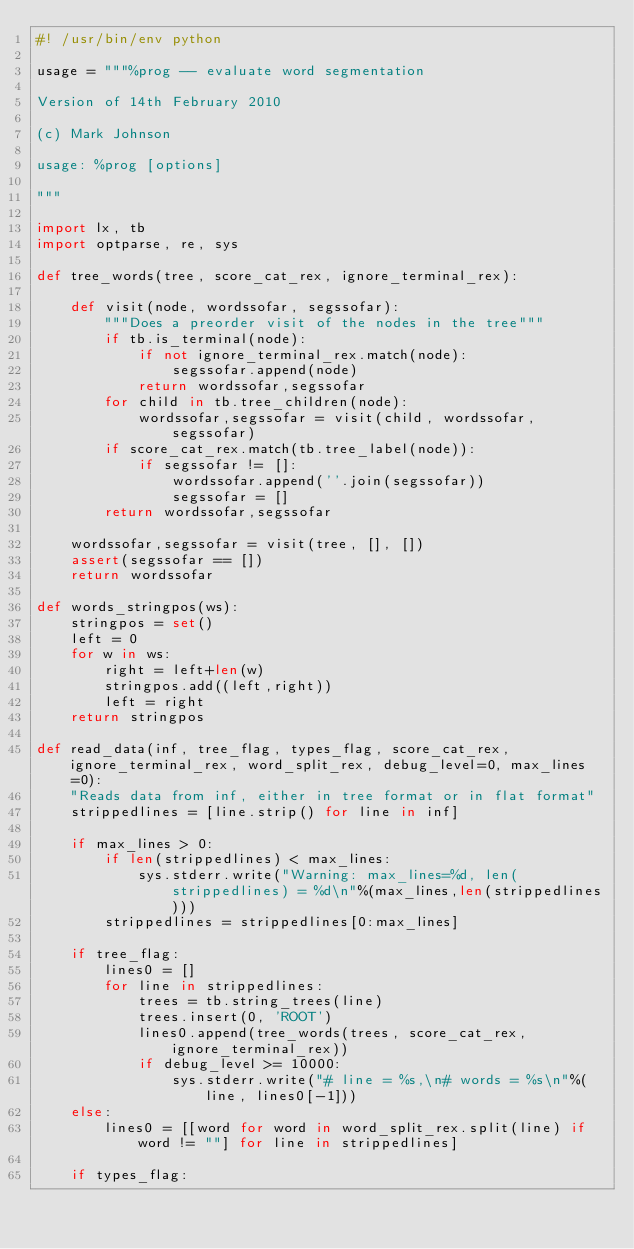<code> <loc_0><loc_0><loc_500><loc_500><_Python_>#! /usr/bin/env python

usage = """%prog -- evaluate word segmentation

Version of 14th February 2010

(c) Mark Johnson

usage: %prog [options]

"""

import lx, tb
import optparse, re, sys

def tree_words(tree, score_cat_rex, ignore_terminal_rex):

    def visit(node, wordssofar, segssofar):
        """Does a preorder visit of the nodes in the tree"""
        if tb.is_terminal(node):
            if not ignore_terminal_rex.match(node):
                segssofar.append(node)
            return wordssofar,segssofar
        for child in tb.tree_children(node):
            wordssofar,segssofar = visit(child, wordssofar, segssofar)
        if score_cat_rex.match(tb.tree_label(node)):
            if segssofar != []:
                wordssofar.append(''.join(segssofar))
                segssofar = []
        return wordssofar,segssofar

    wordssofar,segssofar = visit(tree, [], [])
    assert(segssofar == [])
    return wordssofar

def words_stringpos(ws):
    stringpos = set()
    left = 0
    for w in ws:
        right = left+len(w)
        stringpos.add((left,right))
        left = right
    return stringpos
    
def read_data(inf, tree_flag, types_flag, score_cat_rex, ignore_terminal_rex, word_split_rex, debug_level=0, max_lines=0):
    "Reads data from inf, either in tree format or in flat format"
    strippedlines = [line.strip() for line in inf]

    if max_lines > 0:
        if len(strippedlines) < max_lines:
            sys.stderr.write("Warning: max_lines=%d, len(strippedlines) = %d\n"%(max_lines,len(strippedlines)))
        strippedlines = strippedlines[0:max_lines]

    if tree_flag:
        lines0 = []
        for line in strippedlines:
            trees = tb.string_trees(line)
            trees.insert(0, 'ROOT')
            lines0.append(tree_words(trees, score_cat_rex, ignore_terminal_rex))
            if debug_level >= 10000:
                sys.stderr.write("# line = %s,\n# words = %s\n"%(line, lines0[-1]))
    else:
        lines0 = [[word for word in word_split_rex.split(line) if word != ""] for line in strippedlines]

    if types_flag:</code> 